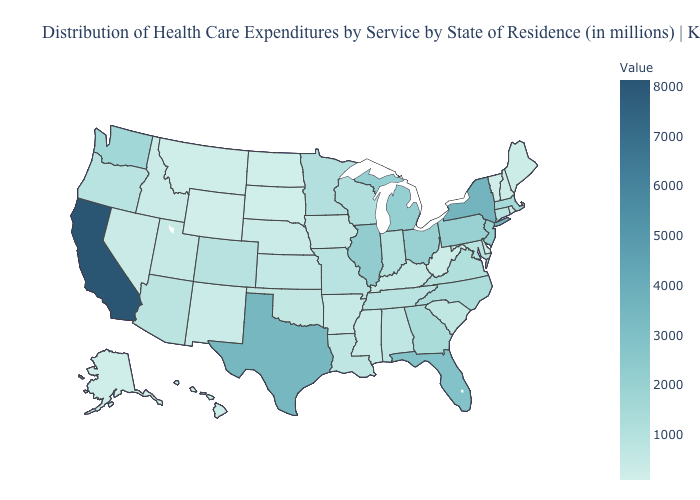Which states have the lowest value in the USA?
Write a very short answer. Wyoming. Among the states that border Arkansas , which have the lowest value?
Be succinct. Mississippi. Does the map have missing data?
Write a very short answer. No. Among the states that border Washington , does Oregon have the lowest value?
Be succinct. No. Among the states that border Vermont , which have the highest value?
Give a very brief answer. New York. Among the states that border Colorado , does Arizona have the highest value?
Give a very brief answer. Yes. 